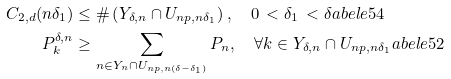Convert formula to latex. <formula><loc_0><loc_0><loc_500><loc_500>C _ { 2 , d } ( n \delta _ { 1 } ) & \leq \# \left ( Y _ { \delta , n } \cap U _ { n { p } , n \delta _ { 1 } } \right ) , \quad 0 \, < \delta _ { 1 } \, < \delta \L a b e l { e 5 4 } \\ P _ { k } ^ { \delta , n } & \geq \sum _ { { n } \in Y _ { n } \cap U _ { n { p } , n ( \delta - \delta _ { 1 } ) } } P _ { n } , \quad \forall { k } \in Y _ { \delta , n } \cap U _ { n { p } , n \delta _ { 1 } } \L a b e l { e 5 2 }</formula> 